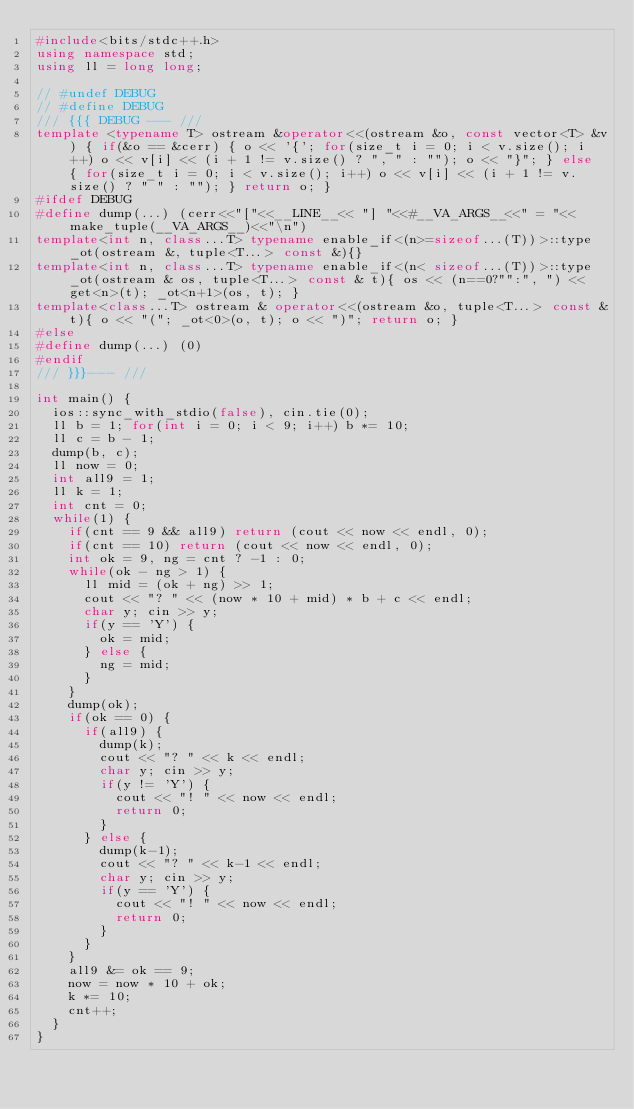<code> <loc_0><loc_0><loc_500><loc_500><_C++_>#include<bits/stdc++.h>
using namespace std;
using ll = long long;

// #undef DEBUG
// #define DEBUG
/// {{{ DEBUG --- ///
template <typename T> ostream &operator<<(ostream &o, const vector<T> &v) { if(&o == &cerr) { o << '{'; for(size_t i = 0; i < v.size(); i++) o << v[i] << (i + 1 != v.size() ? ", " : ""); o << "}"; } else { for(size_t i = 0; i < v.size(); i++) o << v[i] << (i + 1 != v.size() ? " " : ""); } return o; }
#ifdef DEBUG
#define dump(...) (cerr<<"["<<__LINE__<< "] "<<#__VA_ARGS__<<" = "<<make_tuple(__VA_ARGS__)<<"\n")
template<int n, class...T> typename enable_if<(n>=sizeof...(T))>::type _ot(ostream &, tuple<T...> const &){}
template<int n, class...T> typename enable_if<(n< sizeof...(T))>::type _ot(ostream & os, tuple<T...> const & t){ os << (n==0?"":", ") << get<n>(t); _ot<n+1>(os, t); }
template<class...T> ostream & operator<<(ostream &o, tuple<T...> const &t){ o << "("; _ot<0>(o, t); o << ")"; return o; }
#else
#define dump(...) (0)
#endif
/// }}}--- ///

int main() {
  ios::sync_with_stdio(false), cin.tie(0);
  ll b = 1; for(int i = 0; i < 9; i++) b *= 10;
  ll c = b - 1;
  dump(b, c);
  ll now = 0;
  int all9 = 1;
  ll k = 1;
  int cnt = 0;
  while(1) {
    if(cnt == 9 && all9) return (cout << now << endl, 0);
    if(cnt == 10) return (cout << now << endl, 0);
    int ok = 9, ng = cnt ? -1 : 0;
    while(ok - ng > 1) {
      ll mid = (ok + ng) >> 1;
      cout << "? " << (now * 10 + mid) * b + c << endl;
      char y; cin >> y;
      if(y == 'Y') {
        ok = mid;
      } else {
        ng = mid;
      }
    }
    dump(ok);
    if(ok == 0) {
      if(all9) {
        dump(k);
        cout << "? " << k << endl;
        char y; cin >> y;
        if(y != 'Y') {
          cout << "! " << now << endl;
          return 0;
        }
      } else {
        dump(k-1);
        cout << "? " << k-1 << endl;
        char y; cin >> y;
        if(y == 'Y') {
          cout << "! " << now << endl;
          return 0;
        }
      }
    }
    all9 &= ok == 9;
    now = now * 10 + ok;
    k *= 10;
    cnt++;
  }
}

</code> 